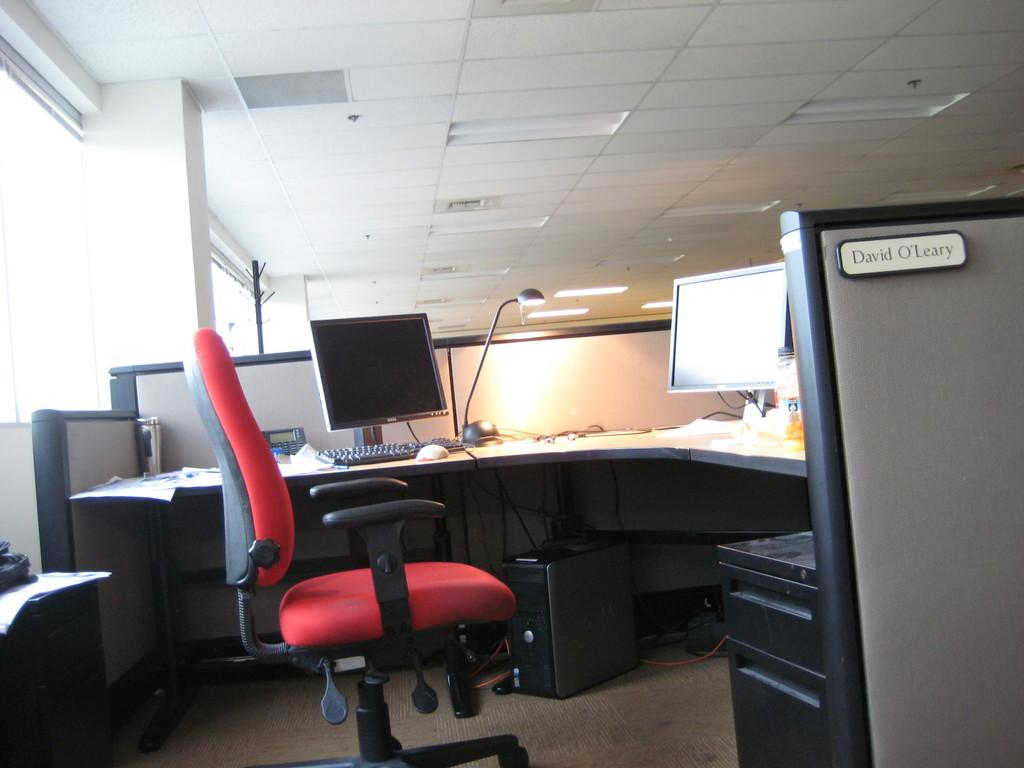Provide a one-sentence caption for the provided image. The cubicle of David O'Leary is shown, with a red chair and two computer monitors. 